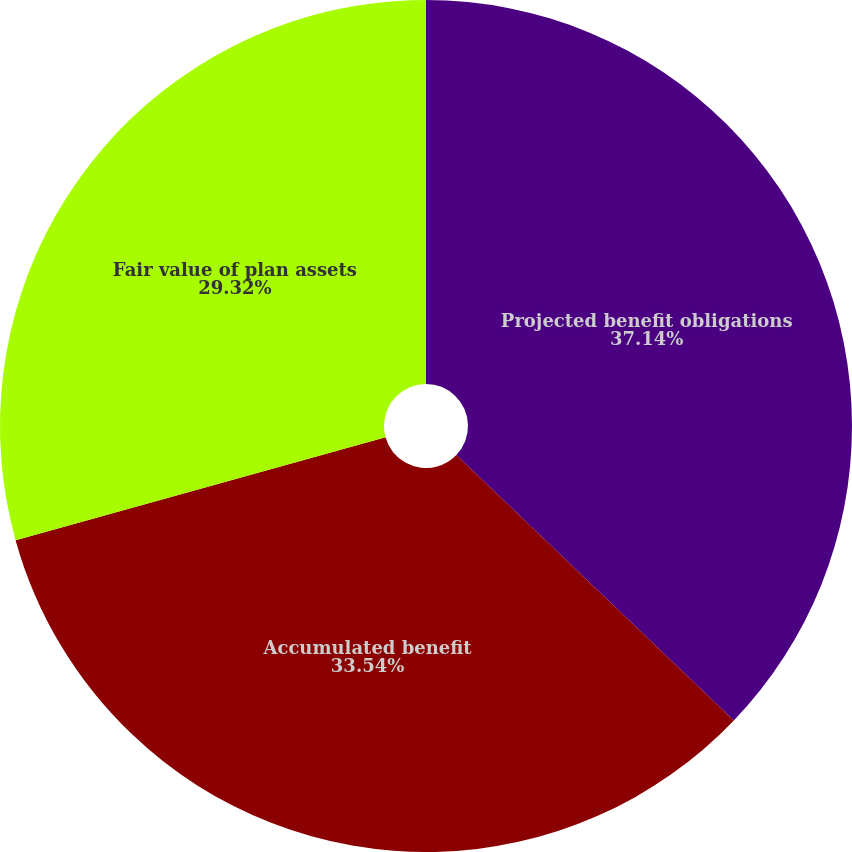Convert chart to OTSL. <chart><loc_0><loc_0><loc_500><loc_500><pie_chart><fcel>Projected benefit obligations<fcel>Accumulated benefit<fcel>Fair value of plan assets<nl><fcel>37.15%<fcel>33.54%<fcel>29.32%<nl></chart> 